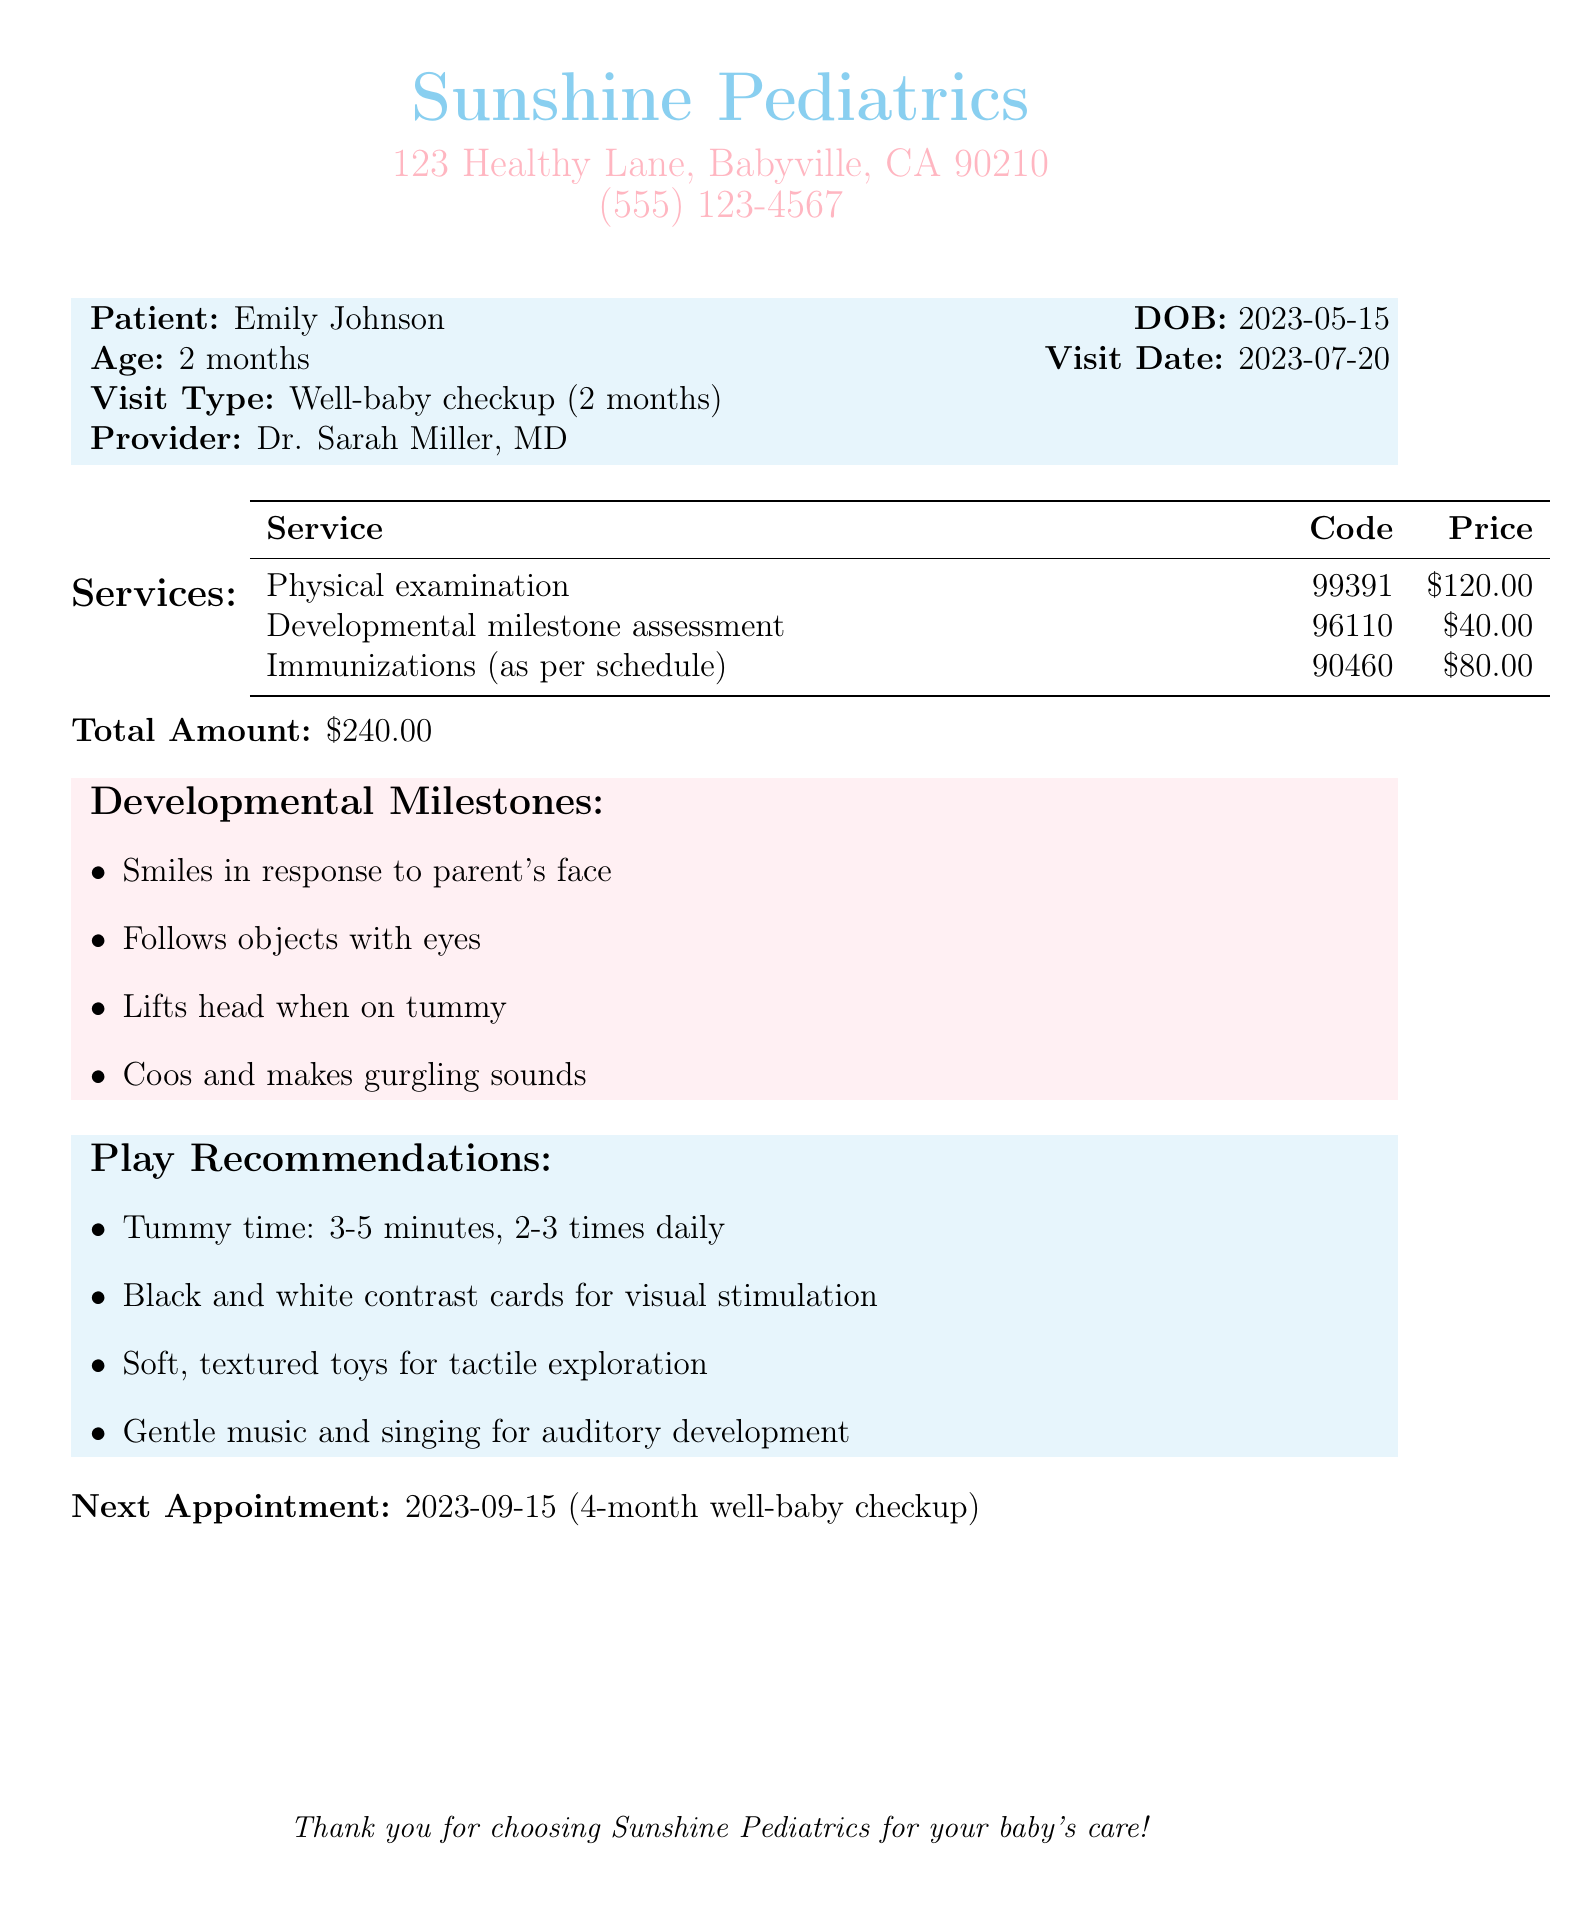What is the patient's name? The patient's name is listed at the top of the document, indicating who the bill is for.
Answer: Emily Johnson What is the date of birth of the patient? The document clearly states the date of birth in the patient information section.
Answer: 2023-05-15 What was the total amount billed? The total amount is summarized at the bottom of the services table.
Answer: $240.00 What are two developmental milestones listed? The document provides a list of developmental milestones under a specific section.
Answer: Smiles in response to parent's face; Follows objects with eyes How many times a day is tummy time recommended? The play recommendations section specifies the frequency of tummy time.
Answer: 2-3 times daily What is the date of the next appointment? The next appointment date is outlined at the end of the document.
Answer: 2023-09-15 Which provider conducted the well-baby checkup? The provider's name is mentioned in the patient information section.
Answer: Dr. Sarah Miller, MD How much was charged for the developmental milestone assessment? This price is included in the services table under the corresponding service.
Answer: $40.00 What type of cards are recommended for visual stimulation? The play recommendations section suggests specific items for play and stimulation.
Answer: Black and white contrast cards 